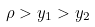Convert formula to latex. <formula><loc_0><loc_0><loc_500><loc_500>\rho > y _ { 1 } > y _ { 2 }</formula> 